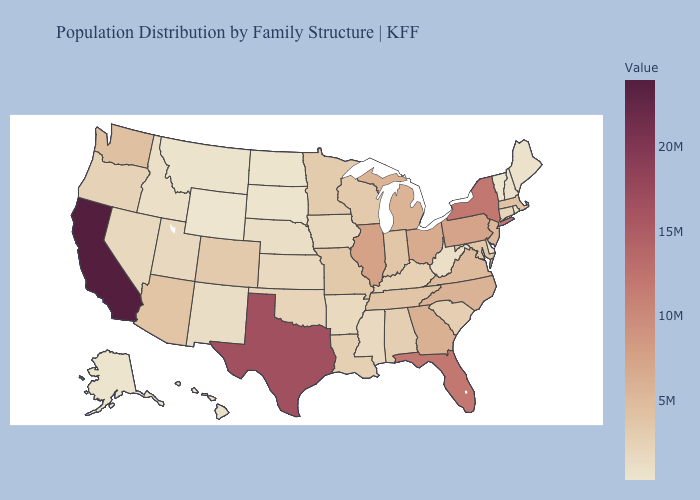Which states hav the highest value in the Northeast?
Keep it brief. New York. Does Missouri have the highest value in the MidWest?
Short answer required. No. Does Wyoming have the lowest value in the USA?
Short answer required. Yes. Is the legend a continuous bar?
Keep it brief. Yes. Among the states that border California , does Nevada have the lowest value?
Concise answer only. Yes. Which states have the lowest value in the USA?
Short answer required. Wyoming. 